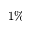Convert formula to latex. <formula><loc_0><loc_0><loc_500><loc_500>1 \%</formula> 